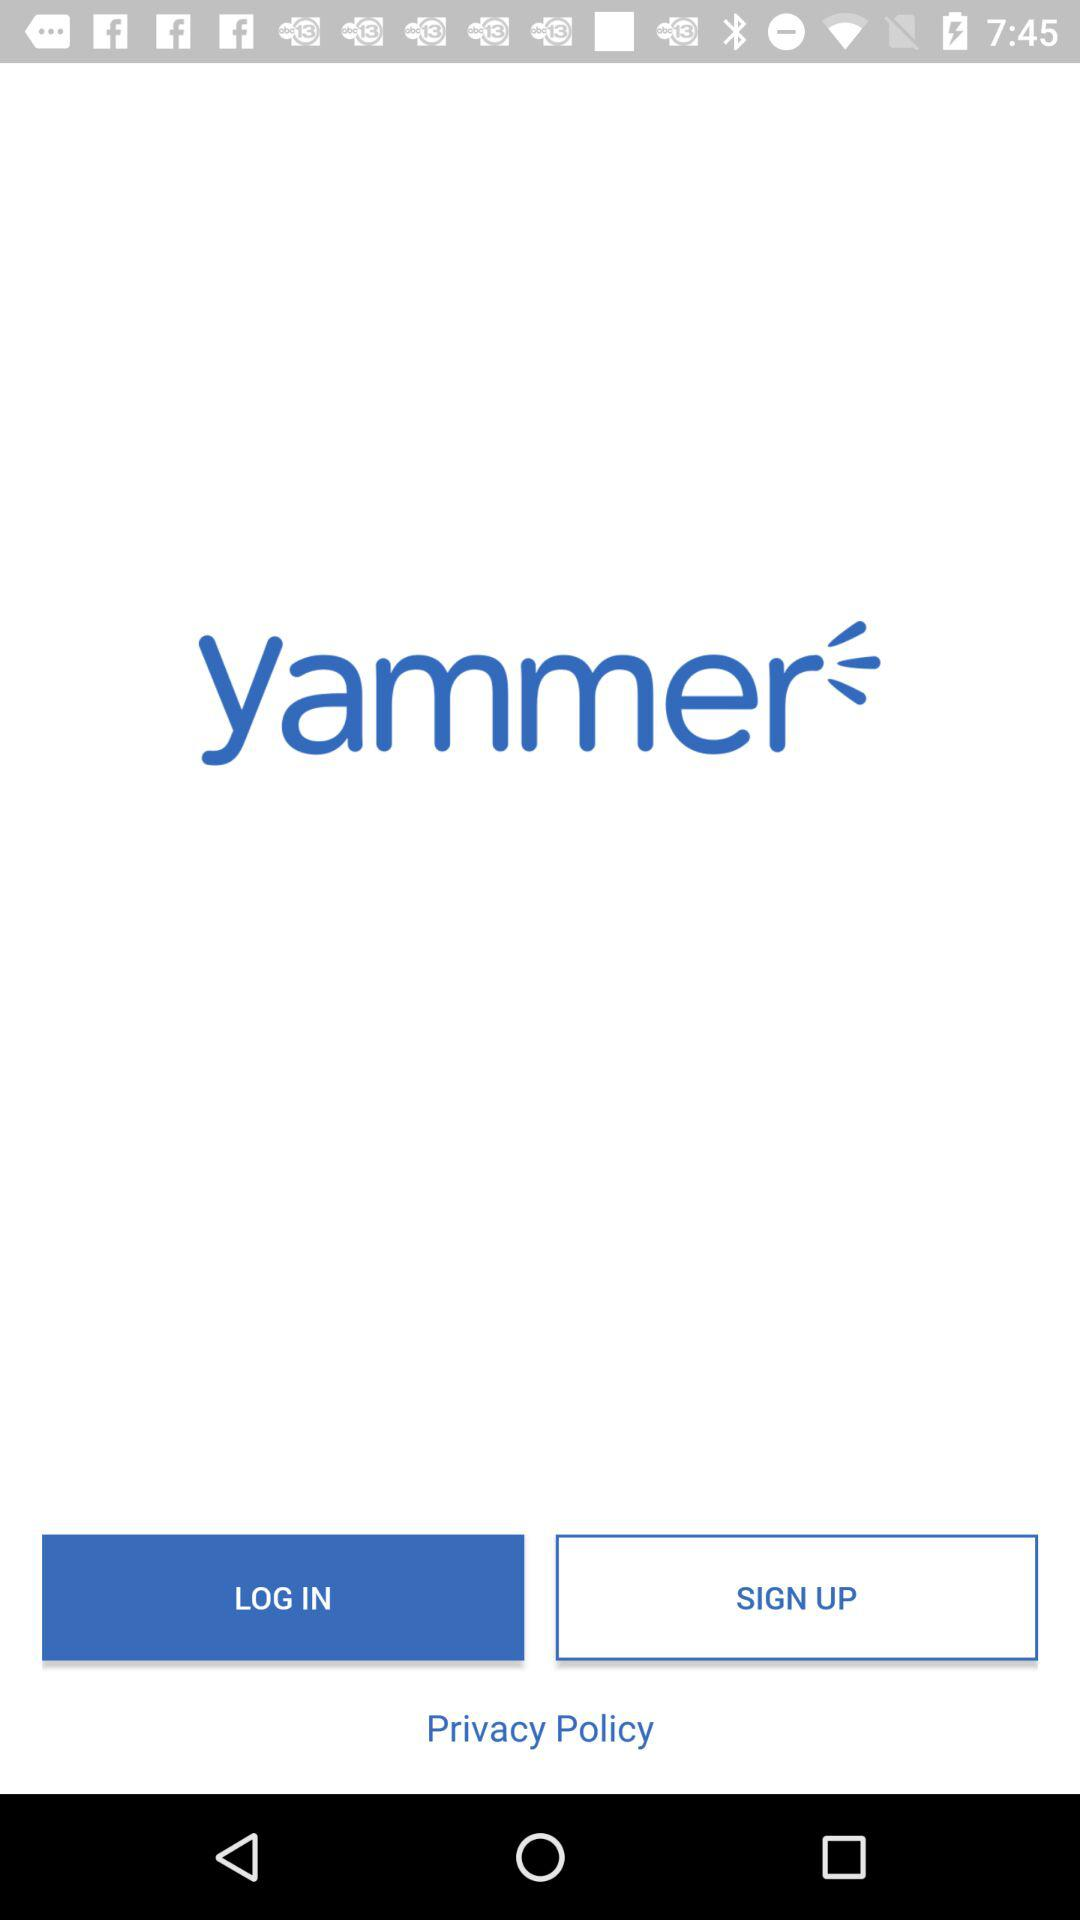What is the app name? The app name is "yammer". 